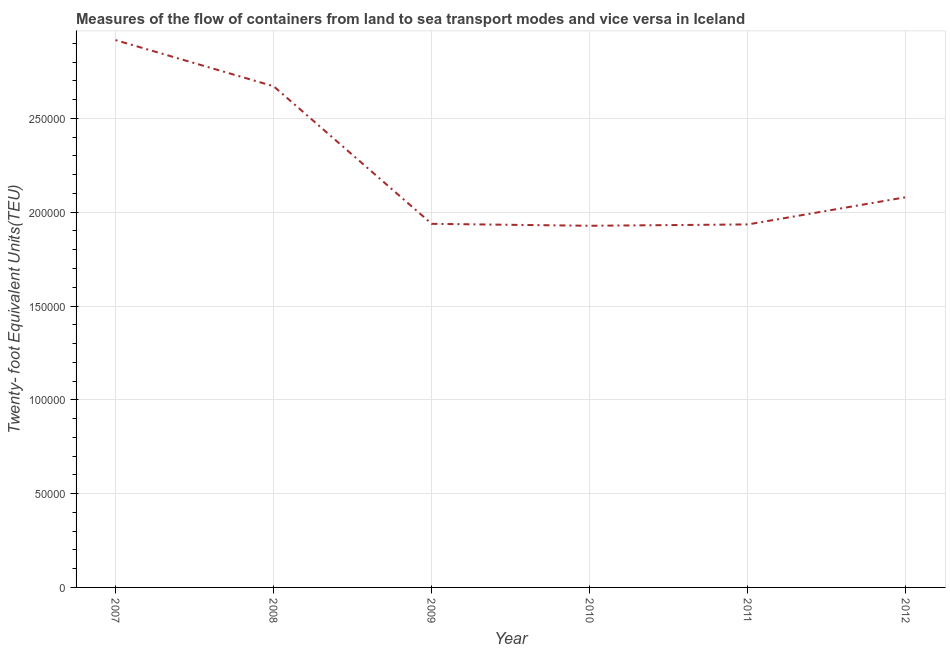What is the container port traffic in 2008?
Your answer should be very brief. 2.67e+05. Across all years, what is the maximum container port traffic?
Your answer should be very brief. 2.92e+05. Across all years, what is the minimum container port traffic?
Make the answer very short. 1.93e+05. In which year was the container port traffic maximum?
Offer a terse response. 2007. What is the sum of the container port traffic?
Keep it short and to the point. 1.35e+06. What is the difference between the container port traffic in 2007 and 2011?
Provide a short and direct response. 9.82e+04. What is the average container port traffic per year?
Offer a terse response. 2.25e+05. What is the median container port traffic?
Give a very brief answer. 2.01e+05. What is the ratio of the container port traffic in 2011 to that in 2012?
Your response must be concise. 0.93. Is the difference between the container port traffic in 2010 and 2011 greater than the difference between any two years?
Provide a short and direct response. No. What is the difference between the highest and the second highest container port traffic?
Your answer should be compact. 2.46e+04. What is the difference between the highest and the lowest container port traffic?
Your response must be concise. 9.90e+04. In how many years, is the container port traffic greater than the average container port traffic taken over all years?
Offer a very short reply. 2. Does the container port traffic monotonically increase over the years?
Make the answer very short. No. Are the values on the major ticks of Y-axis written in scientific E-notation?
Your answer should be compact. No. Does the graph contain grids?
Give a very brief answer. Yes. What is the title of the graph?
Give a very brief answer. Measures of the flow of containers from land to sea transport modes and vice versa in Iceland. What is the label or title of the X-axis?
Your answer should be compact. Year. What is the label or title of the Y-axis?
Provide a short and direct response. Twenty- foot Equivalent Units(TEU). What is the Twenty- foot Equivalent Units(TEU) of 2007?
Your response must be concise. 2.92e+05. What is the Twenty- foot Equivalent Units(TEU) in 2008?
Offer a terse response. 2.67e+05. What is the Twenty- foot Equivalent Units(TEU) of 2009?
Your answer should be compact. 1.94e+05. What is the Twenty- foot Equivalent Units(TEU) in 2010?
Your answer should be compact. 1.93e+05. What is the Twenty- foot Equivalent Units(TEU) of 2011?
Offer a terse response. 1.94e+05. What is the Twenty- foot Equivalent Units(TEU) of 2012?
Your answer should be very brief. 2.08e+05. What is the difference between the Twenty- foot Equivalent Units(TEU) in 2007 and 2008?
Offer a terse response. 2.46e+04. What is the difference between the Twenty- foot Equivalent Units(TEU) in 2007 and 2009?
Make the answer very short. 9.79e+04. What is the difference between the Twenty- foot Equivalent Units(TEU) in 2007 and 2010?
Provide a succinct answer. 9.90e+04. What is the difference between the Twenty- foot Equivalent Units(TEU) in 2007 and 2011?
Give a very brief answer. 9.82e+04. What is the difference between the Twenty- foot Equivalent Units(TEU) in 2007 and 2012?
Offer a very short reply. 8.37e+04. What is the difference between the Twenty- foot Equivalent Units(TEU) in 2008 and 2009?
Make the answer very short. 7.33e+04. What is the difference between the Twenty- foot Equivalent Units(TEU) in 2008 and 2010?
Your response must be concise. 7.44e+04. What is the difference between the Twenty- foot Equivalent Units(TEU) in 2008 and 2011?
Offer a very short reply. 7.37e+04. What is the difference between the Twenty- foot Equivalent Units(TEU) in 2008 and 2012?
Your response must be concise. 5.91e+04. What is the difference between the Twenty- foot Equivalent Units(TEU) in 2009 and 2010?
Make the answer very short. 1038. What is the difference between the Twenty- foot Equivalent Units(TEU) in 2009 and 2011?
Provide a short and direct response. 316. What is the difference between the Twenty- foot Equivalent Units(TEU) in 2009 and 2012?
Ensure brevity in your answer.  -1.42e+04. What is the difference between the Twenty- foot Equivalent Units(TEU) in 2010 and 2011?
Provide a succinct answer. -722. What is the difference between the Twenty- foot Equivalent Units(TEU) in 2010 and 2012?
Ensure brevity in your answer.  -1.52e+04. What is the difference between the Twenty- foot Equivalent Units(TEU) in 2011 and 2012?
Offer a very short reply. -1.45e+04. What is the ratio of the Twenty- foot Equivalent Units(TEU) in 2007 to that in 2008?
Provide a short and direct response. 1.09. What is the ratio of the Twenty- foot Equivalent Units(TEU) in 2007 to that in 2009?
Provide a short and direct response. 1.5. What is the ratio of the Twenty- foot Equivalent Units(TEU) in 2007 to that in 2010?
Keep it short and to the point. 1.51. What is the ratio of the Twenty- foot Equivalent Units(TEU) in 2007 to that in 2011?
Your response must be concise. 1.51. What is the ratio of the Twenty- foot Equivalent Units(TEU) in 2007 to that in 2012?
Offer a very short reply. 1.4. What is the ratio of the Twenty- foot Equivalent Units(TEU) in 2008 to that in 2009?
Ensure brevity in your answer.  1.38. What is the ratio of the Twenty- foot Equivalent Units(TEU) in 2008 to that in 2010?
Offer a very short reply. 1.39. What is the ratio of the Twenty- foot Equivalent Units(TEU) in 2008 to that in 2011?
Ensure brevity in your answer.  1.38. What is the ratio of the Twenty- foot Equivalent Units(TEU) in 2008 to that in 2012?
Offer a very short reply. 1.28. What is the ratio of the Twenty- foot Equivalent Units(TEU) in 2009 to that in 2012?
Offer a terse response. 0.93. What is the ratio of the Twenty- foot Equivalent Units(TEU) in 2010 to that in 2011?
Give a very brief answer. 1. What is the ratio of the Twenty- foot Equivalent Units(TEU) in 2010 to that in 2012?
Provide a short and direct response. 0.93. 